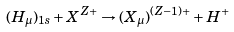<formula> <loc_0><loc_0><loc_500><loc_500>( H _ { \mu } ) _ { 1 s } + { X ^ { Z + } } \rightarrow ( X _ { \mu } ) ^ { ( Z - 1 ) + } + H ^ { + }</formula> 